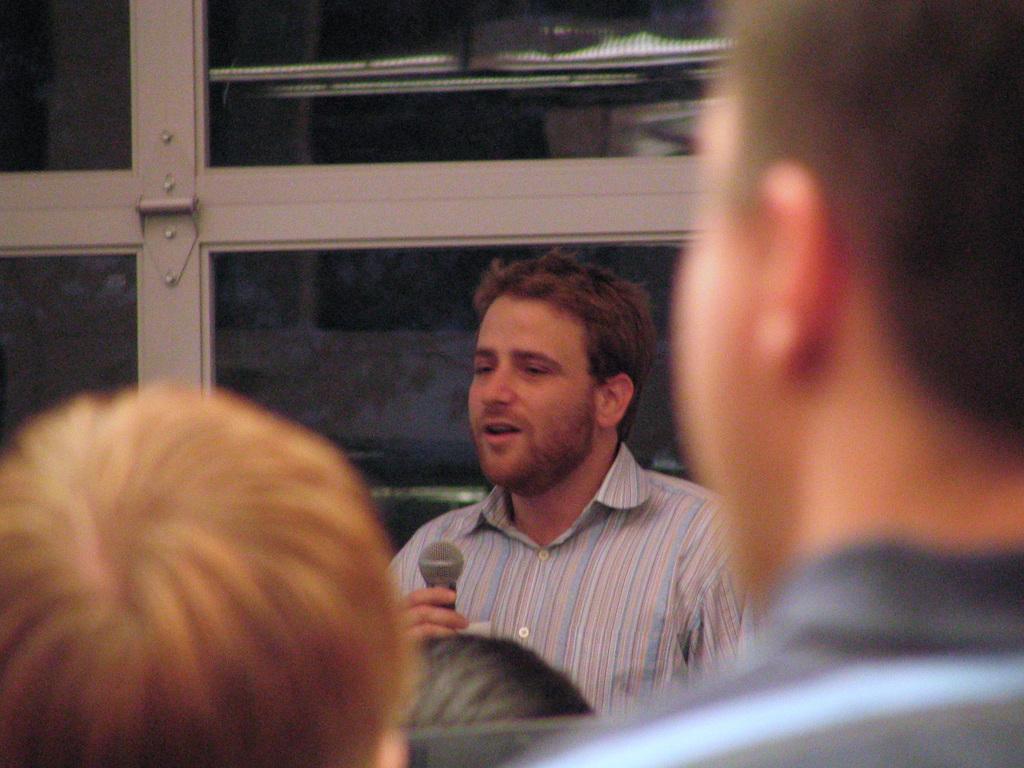Please provide a concise description of this image. In this picture there is a man holding a mike. At the bottom, there are people facing backwards. On the top, there is a glass window. 